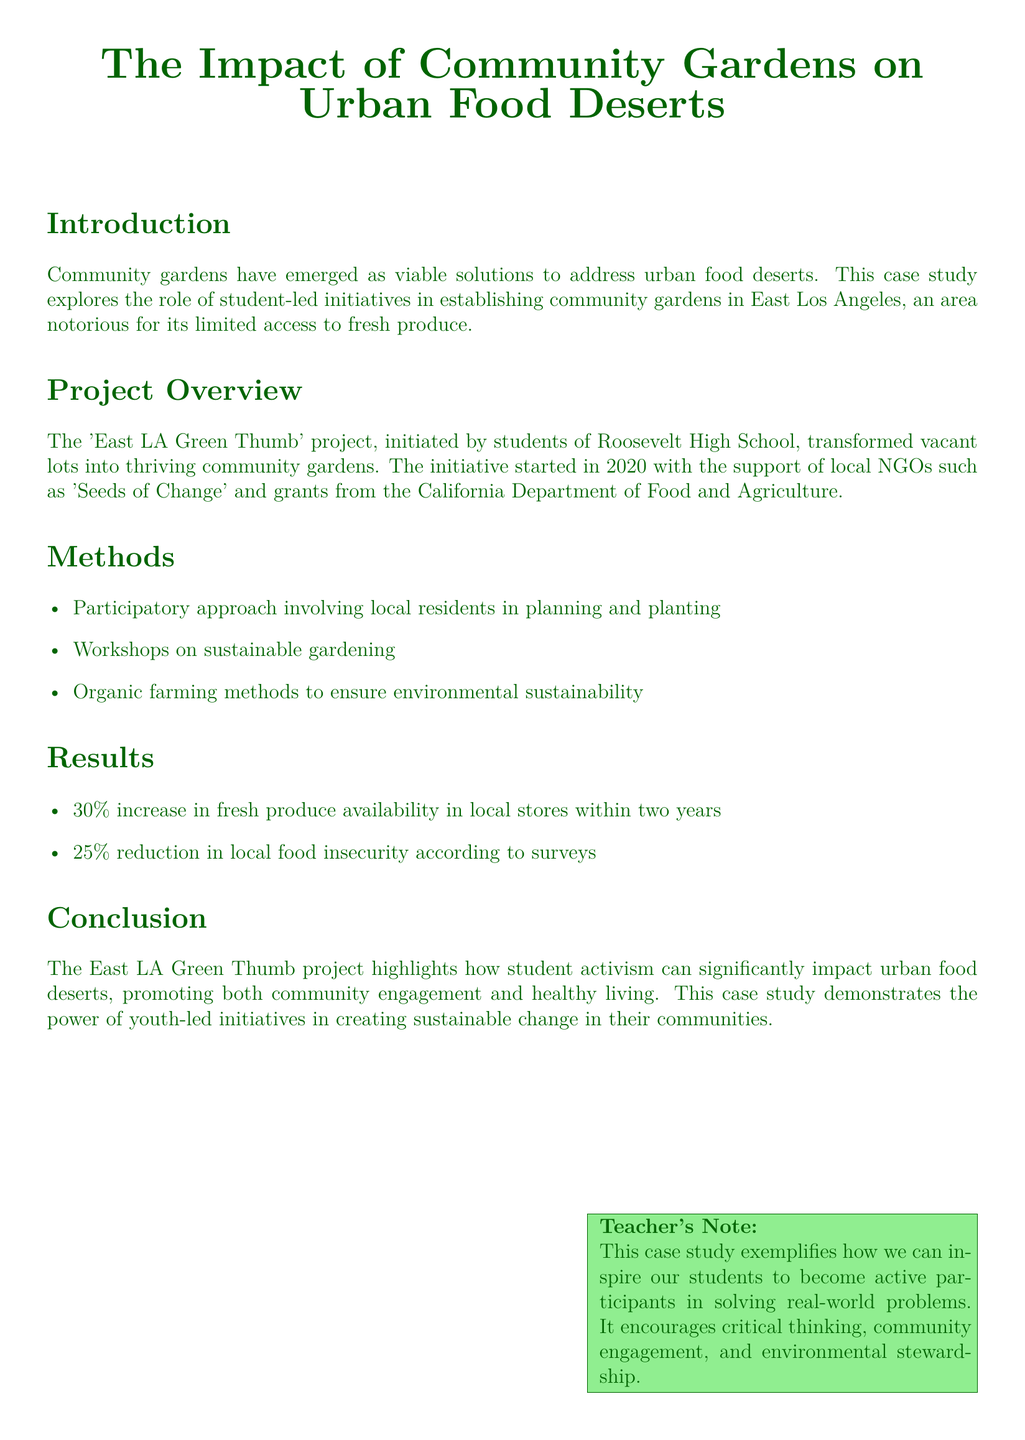What is the name of the project? The name of the project is mentioned in the document as 'East LA Green Thumb'.
Answer: East LA Green Thumb Which school initiated the community garden project? The document specifies that the project was initiated by students of Roosevelt High School.
Answer: Roosevelt High School What percentage increase in fresh produce availability was reported? The document states a 30% increase in fresh produce availability in local stores within two years.
Answer: 30% What was the reduction in local food insecurity according to surveys? According to the surveys mentioned in the document, there was a 25% reduction in local food insecurity.
Answer: 25% Which organization provided support for the project? The document identifies 'Seeds of Change' as an organization that supported the project.
Answer: Seeds of Change How many years did the project run to observe the results? The results mentioned in the document were observed over a period of two years.
Answer: Two years What approach did the project use to involve local residents? The document states that a participatory approach was used to involve local residents in planning and planting.
Answer: Participatory approach What does this case study exemplify in terms of student involvement? The case study exemplifies how student activism can significantly impact urban food deserts.
Answer: Student activism 